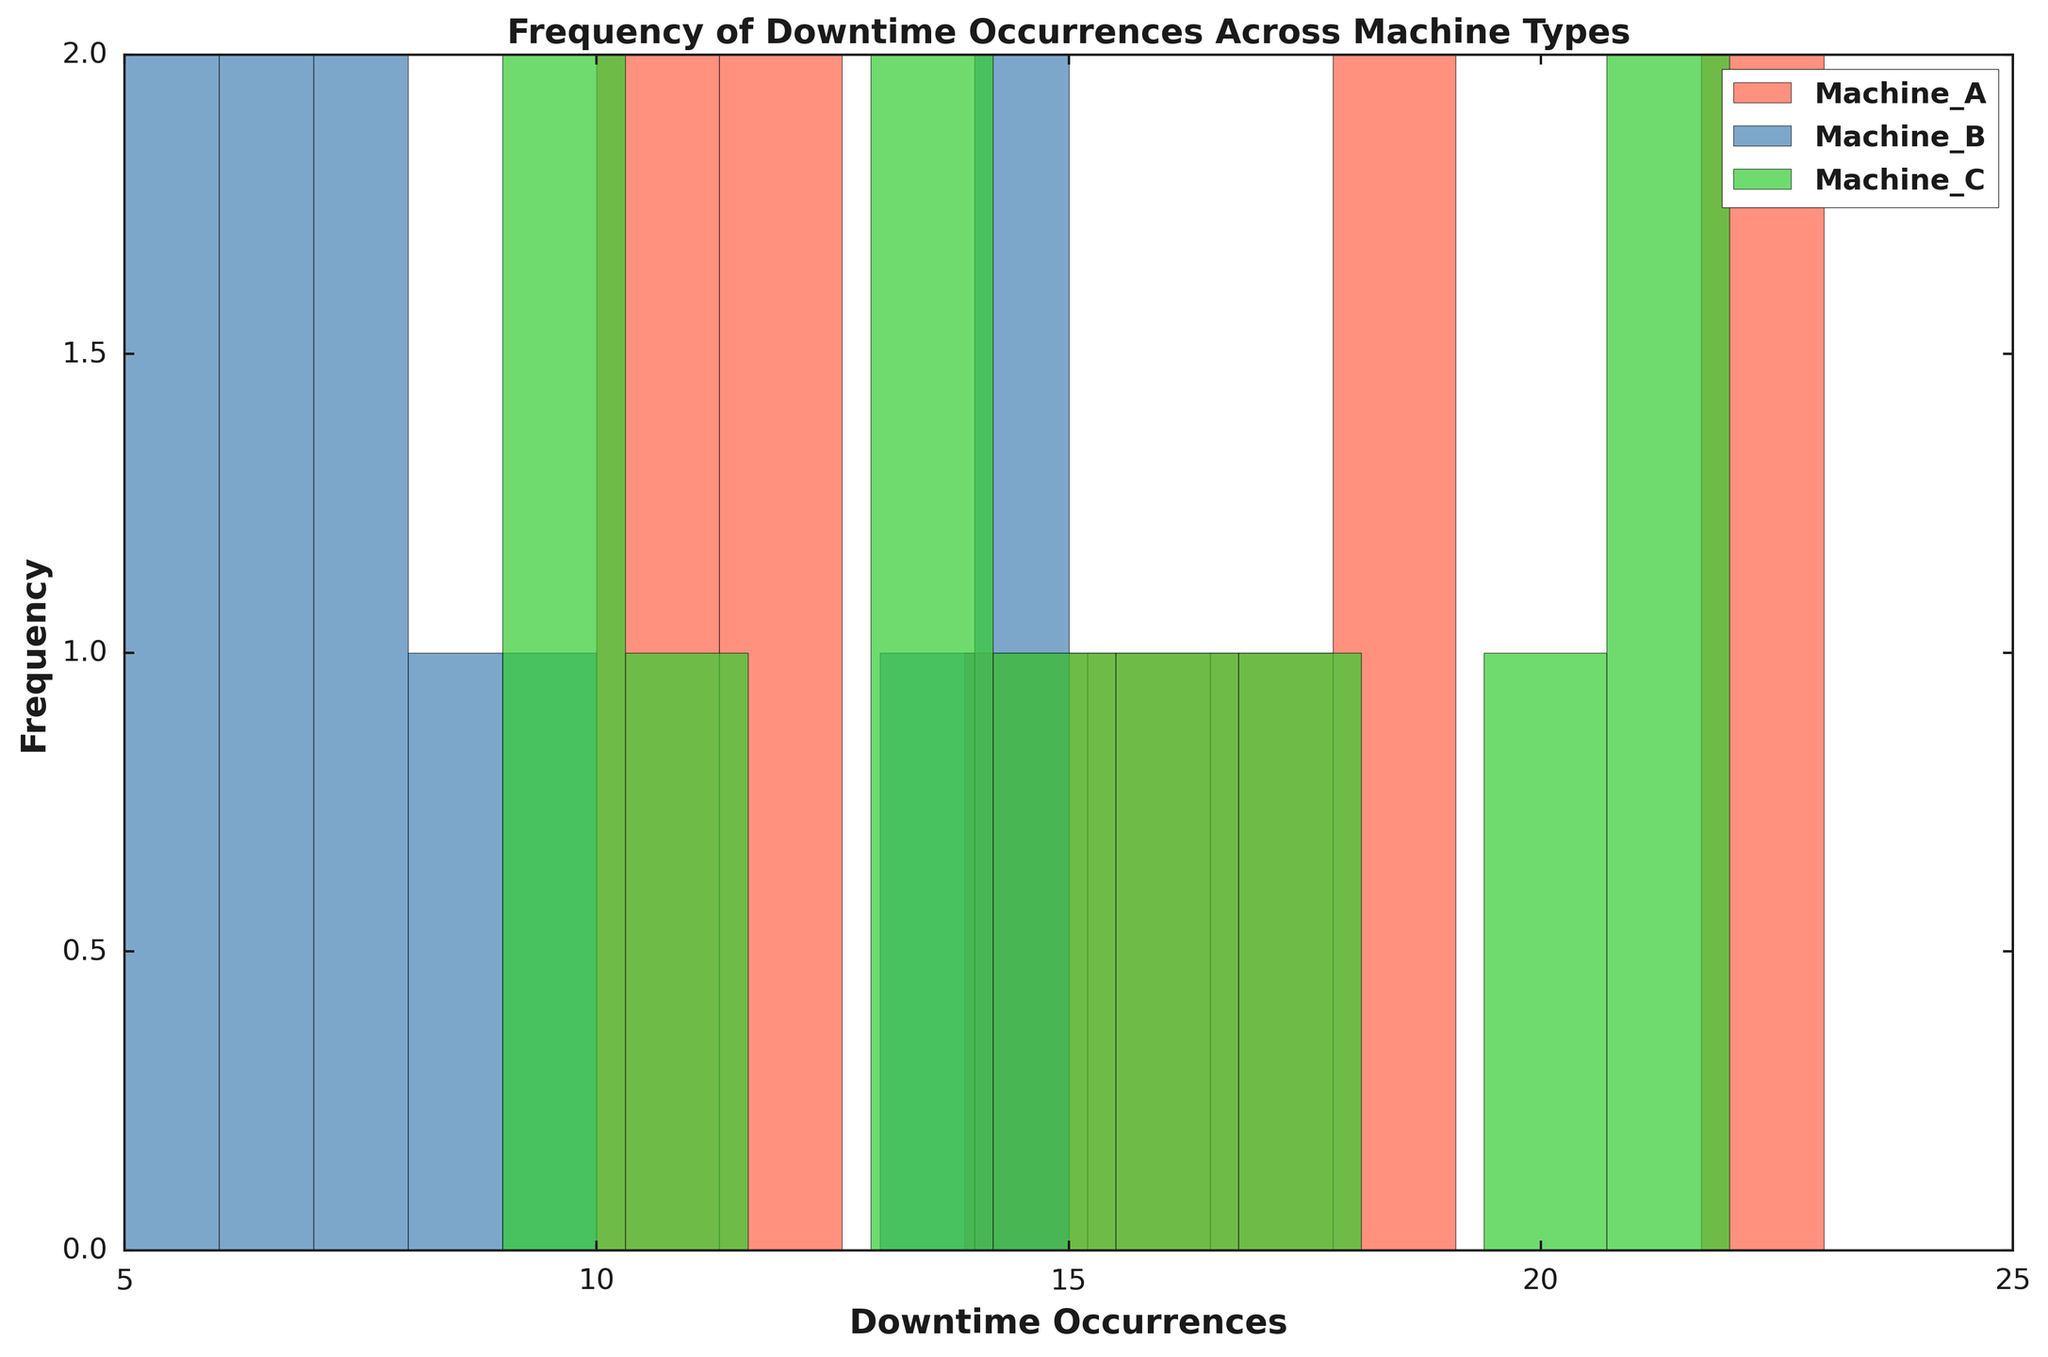What machine type has the highest frequency of downtime occurrences? To determine which machine type has the highest frequency of downtime occurrences, observe the peaks of the histogram bars and compare them. In this case, the highest peaks are for Machine C.
Answer: Machine C Which machine type has the lowest frequency of downtime occurrences? To identify the machine type with the lowest frequency of downtime occurrences, look for the histogram with the generally shortest bars. Here, Machine B has the lowest overall frequency.
Answer: Machine B What is the average downtime occurrence for Machine A? Sum the individual downtime occurrences for Machine A (12, 18, 10, 23, 17, 14, 22, 16, 12, 19, 11) and divide by the total count of occurrences (11). The sum is 174, so the average is 174/11.
Answer: 15.82 Which machine type has the most downtime occurrences in the 20-25 range? Look at the histogram bins corresponding to the range 20-25 for each machine type. The tallest bar within this bin belongs to Machine C.
Answer: Machine C Between Machines A and B, which has a higher peak frequency in the histogram? Compare the tallest bars from the histograms of Machines A and B. Machine A's highest bars are taller than Machine B's highest bars.
Answer: Machine A What is the median downtime occurrence for Machine B? First, list all downtime occurrences for Machine B and arrange them in ascending order (5, 5, 6, 6, 7, 7, 8, 9, 13, 14, 15). Since there are 11 values, the median is the 6th value, which is 7.
Answer: 7 Which machine type has the wider spread of downtime occurrences? Assess the range of values covered by the histogram bars for each machine type. The histogram for Machine C spans the widest range of downtime occurrences.
Answer: Machine C What is the interquartile range (IQR) for Machine C? Arrange the downtime occurrences for Machine C (9, 10, 11, 13, 14, 15, 16, 18, 20, 21, 22) in ascending order. Calculate Q1 (25th percentile = 12.5, rounded to 13) and Q3 (75th percentile = 20.25, rounded to 20). The IQR is Q3 - Q1.
Answer: 7 